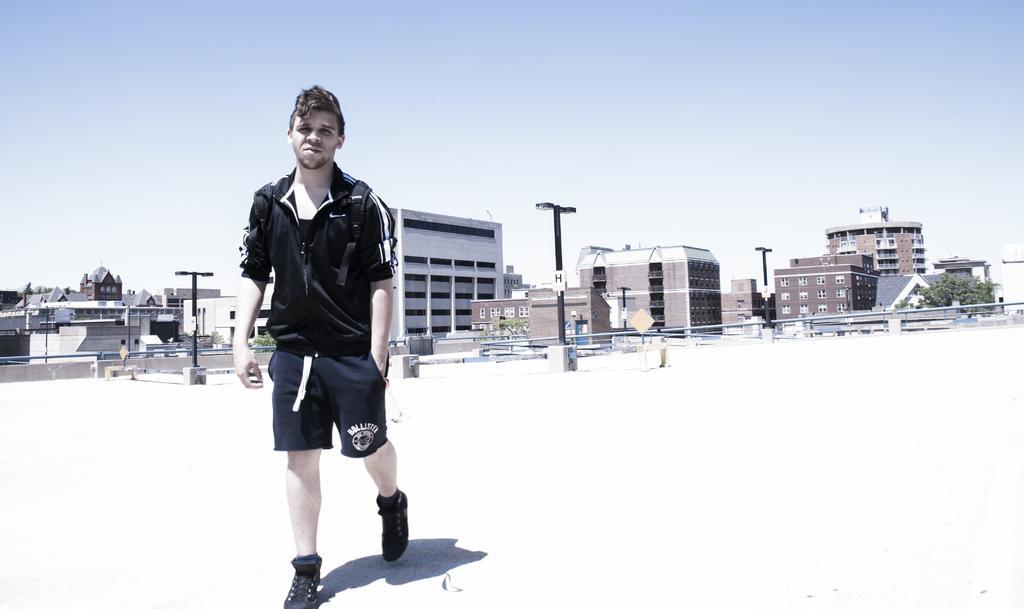Can you describe this image briefly? In the foreground I can see a person. In the background I can see a fence, light poles, trees, buildings and windows. At the top I can see the sky. This image is taken may be during a sunny day. 